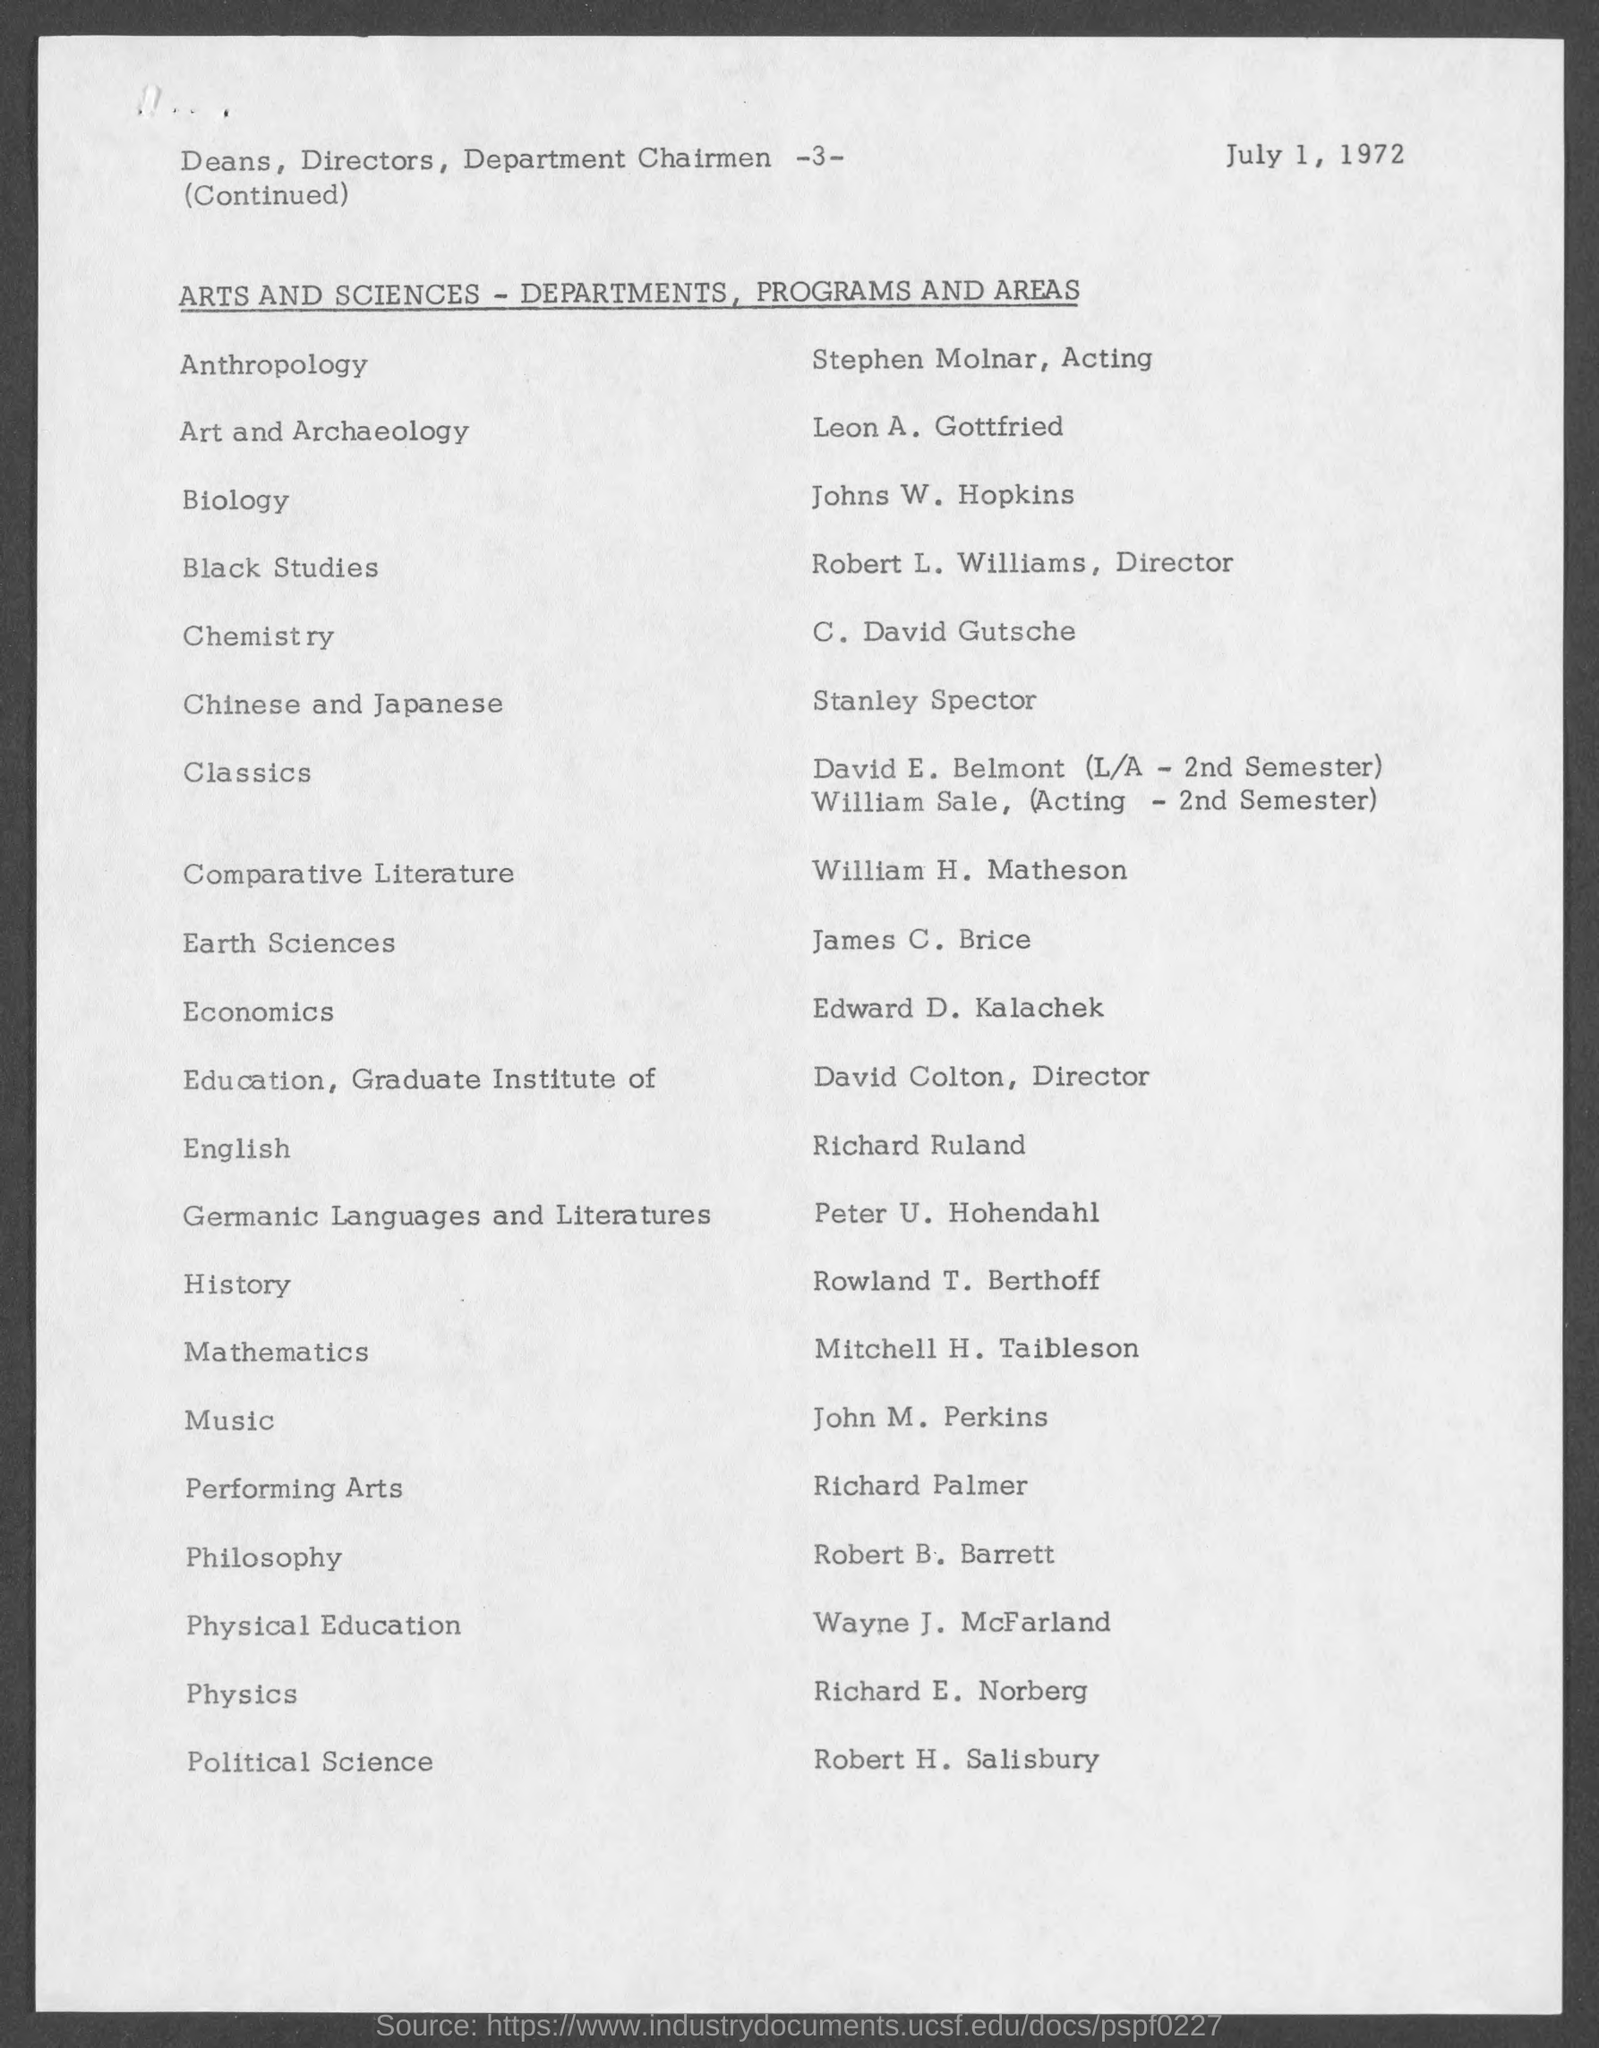What is the date mentioned in this document?
Provide a succinct answer. July 1, 1972. In which department, Johns W. Hopkins works?
Offer a terse response. Biology. Who works in the department of Political Science?
Ensure brevity in your answer.  Robert H. Salisbury. 